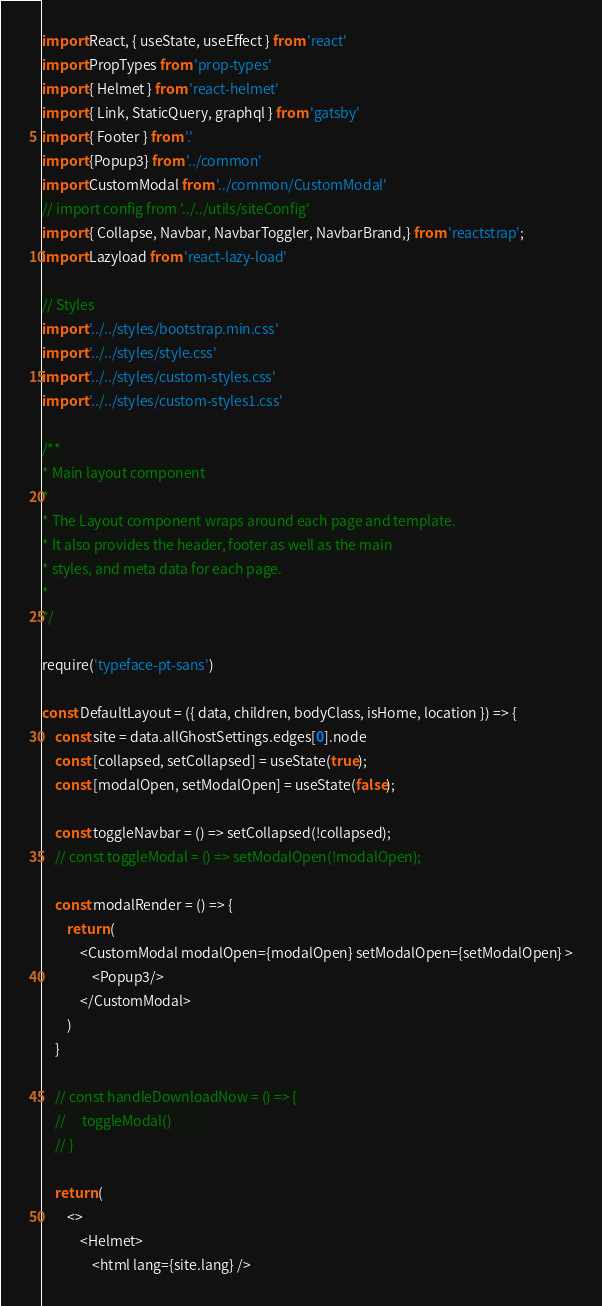<code> <loc_0><loc_0><loc_500><loc_500><_JavaScript_>import React, { useState, useEffect } from 'react'
import PropTypes from 'prop-types'
import { Helmet } from 'react-helmet'
import { Link, StaticQuery, graphql } from 'gatsby'
import { Footer } from '.'
import {Popup3} from '../common'
import CustomModal from '../common/CustomModal'
// import config from '../../utils/siteConfig'
import { Collapse, Navbar, NavbarToggler, NavbarBrand,} from 'reactstrap';
import Lazyload from 'react-lazy-load'

// Styles
import '../../styles/bootstrap.min.css'
import '../../styles/style.css'
import '../../styles/custom-styles.css'
import '../../styles/custom-styles1.css'

/**
* Main layout component
*
* The Layout component wraps around each page and template.
* It also provides the header, footer as well as the main
* styles, and meta data for each page.
*
*/

require('typeface-pt-sans')

const DefaultLayout = ({ data, children, bodyClass, isHome, location }) => {
    const site = data.allGhostSettings.edges[0].node
    const [collapsed, setCollapsed] = useState(true);
    const [modalOpen, setModalOpen] = useState(false);
    
    const toggleNavbar = () => setCollapsed(!collapsed);
    // const toggleModal = () => setModalOpen(!modalOpen);

    const modalRender = () => {
        return (
            <CustomModal modalOpen={modalOpen} setModalOpen={setModalOpen} >
                <Popup3/>
            </CustomModal>
        )
    }
    
    // const handleDownloadNow = () => {
    //     toggleModal()           
    // }

    return (
        <>
            <Helmet>
                <html lang={site.lang} /></code> 